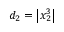Convert formula to latex. <formula><loc_0><loc_0><loc_500><loc_500>d _ { 2 } = \left | x _ { 2 } ^ { 3 } \right |</formula> 